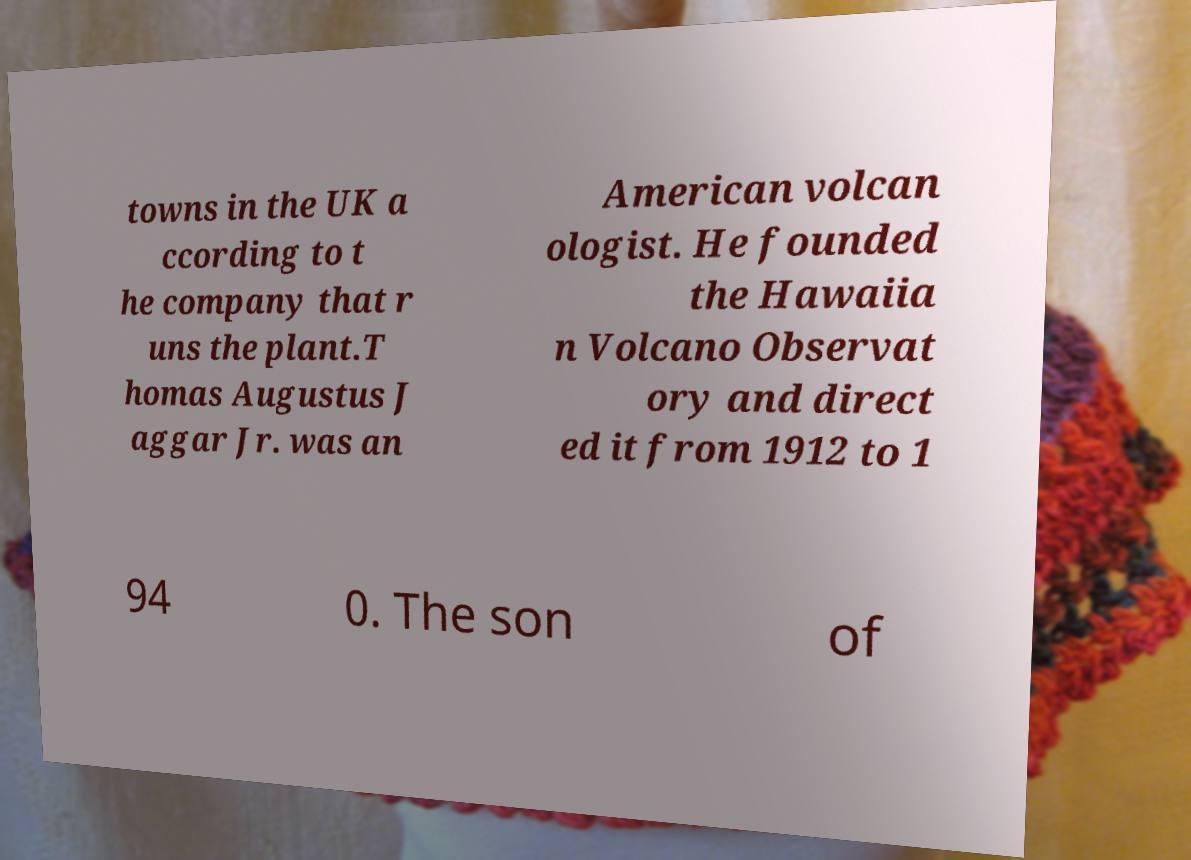Please read and relay the text visible in this image. What does it say? towns in the UK a ccording to t he company that r uns the plant.T homas Augustus J aggar Jr. was an American volcan ologist. He founded the Hawaiia n Volcano Observat ory and direct ed it from 1912 to 1 94 0. The son of 